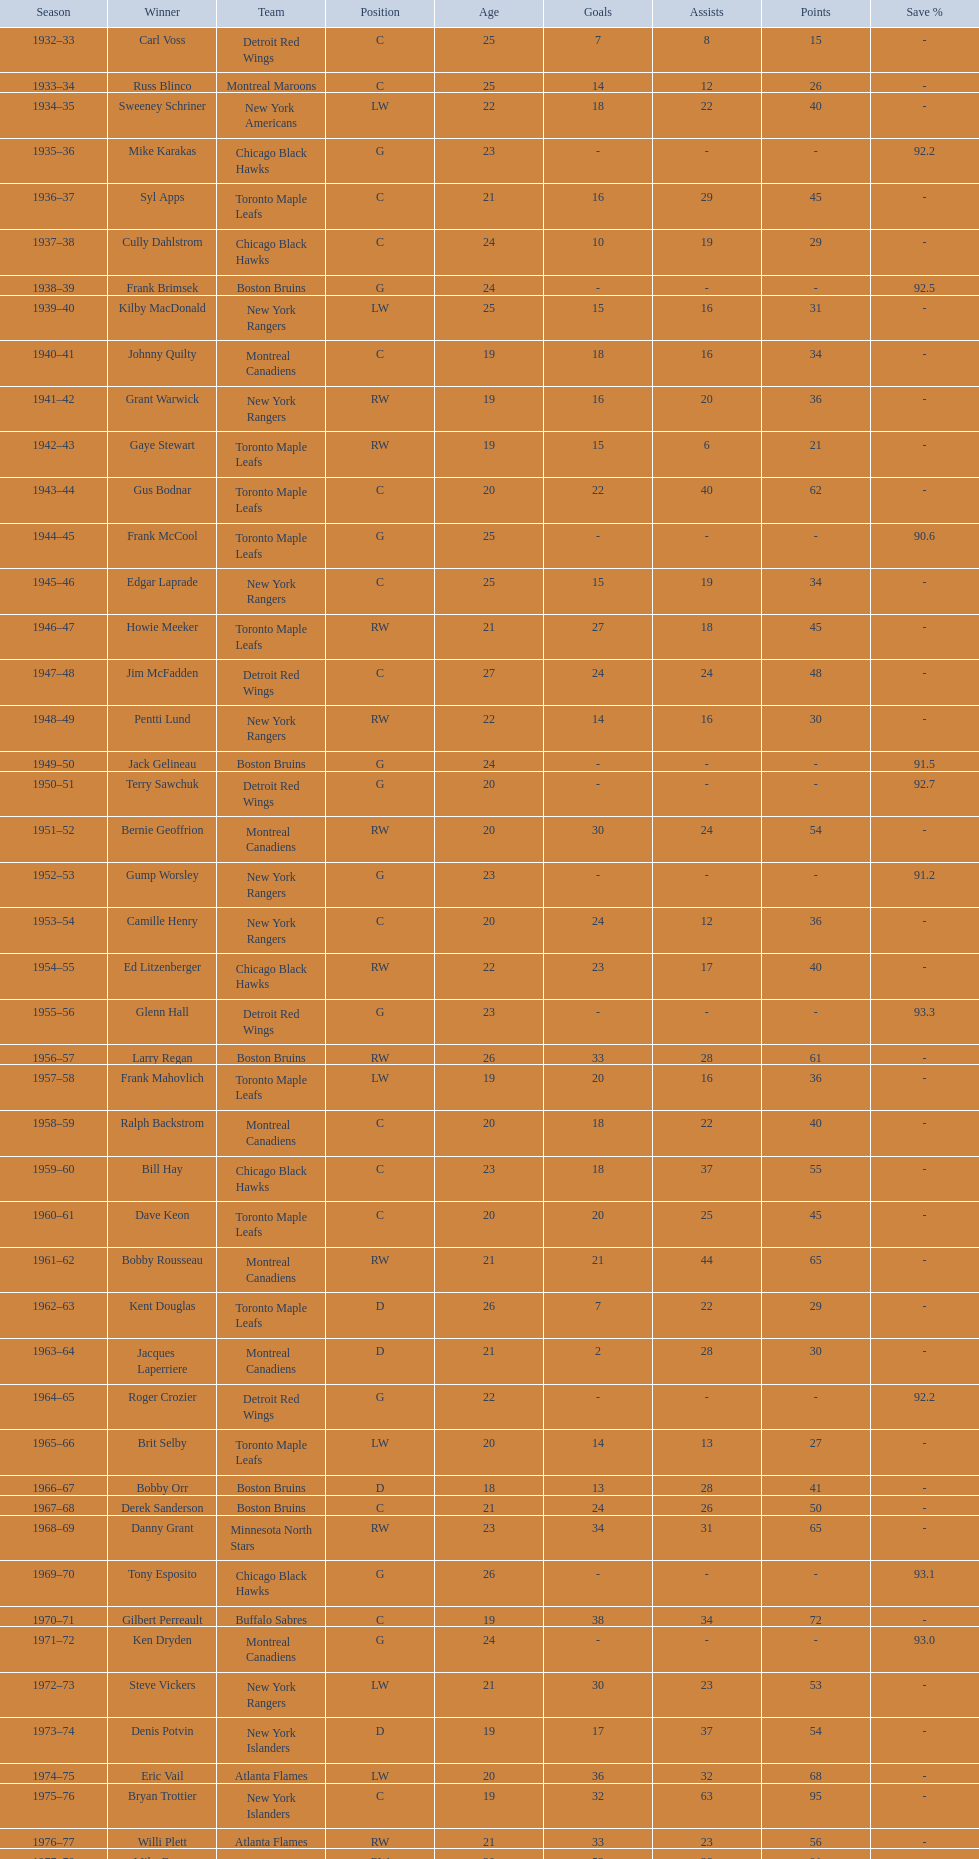Who was the first calder memorial trophy winner from the boston bruins? Frank Brimsek. 